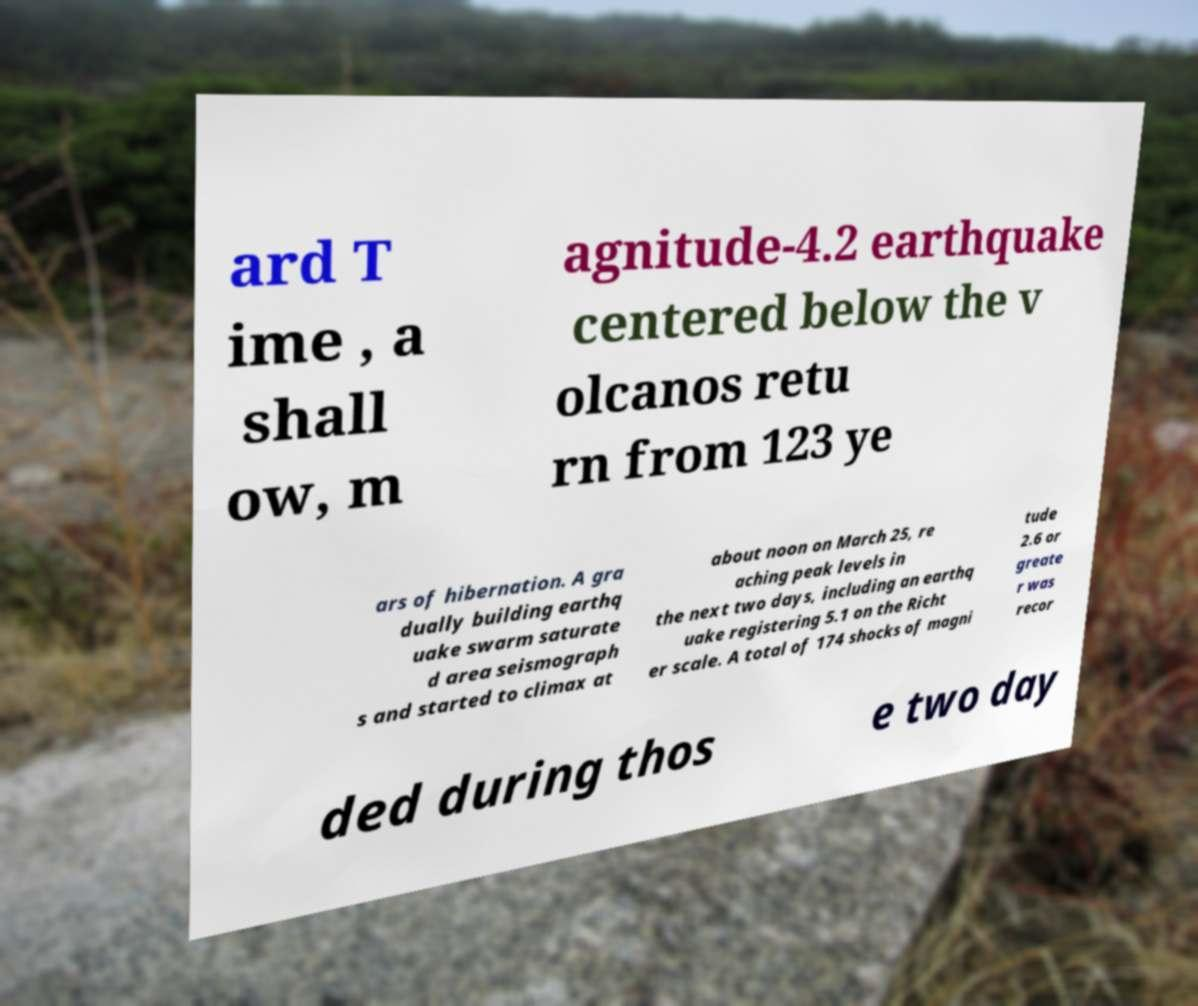Could you assist in decoding the text presented in this image and type it out clearly? ard T ime , a shall ow, m agnitude-4.2 earthquake centered below the v olcanos retu rn from 123 ye ars of hibernation. A gra dually building earthq uake swarm saturate d area seismograph s and started to climax at about noon on March 25, re aching peak levels in the next two days, including an earthq uake registering 5.1 on the Richt er scale. A total of 174 shocks of magni tude 2.6 or greate r was recor ded during thos e two day 